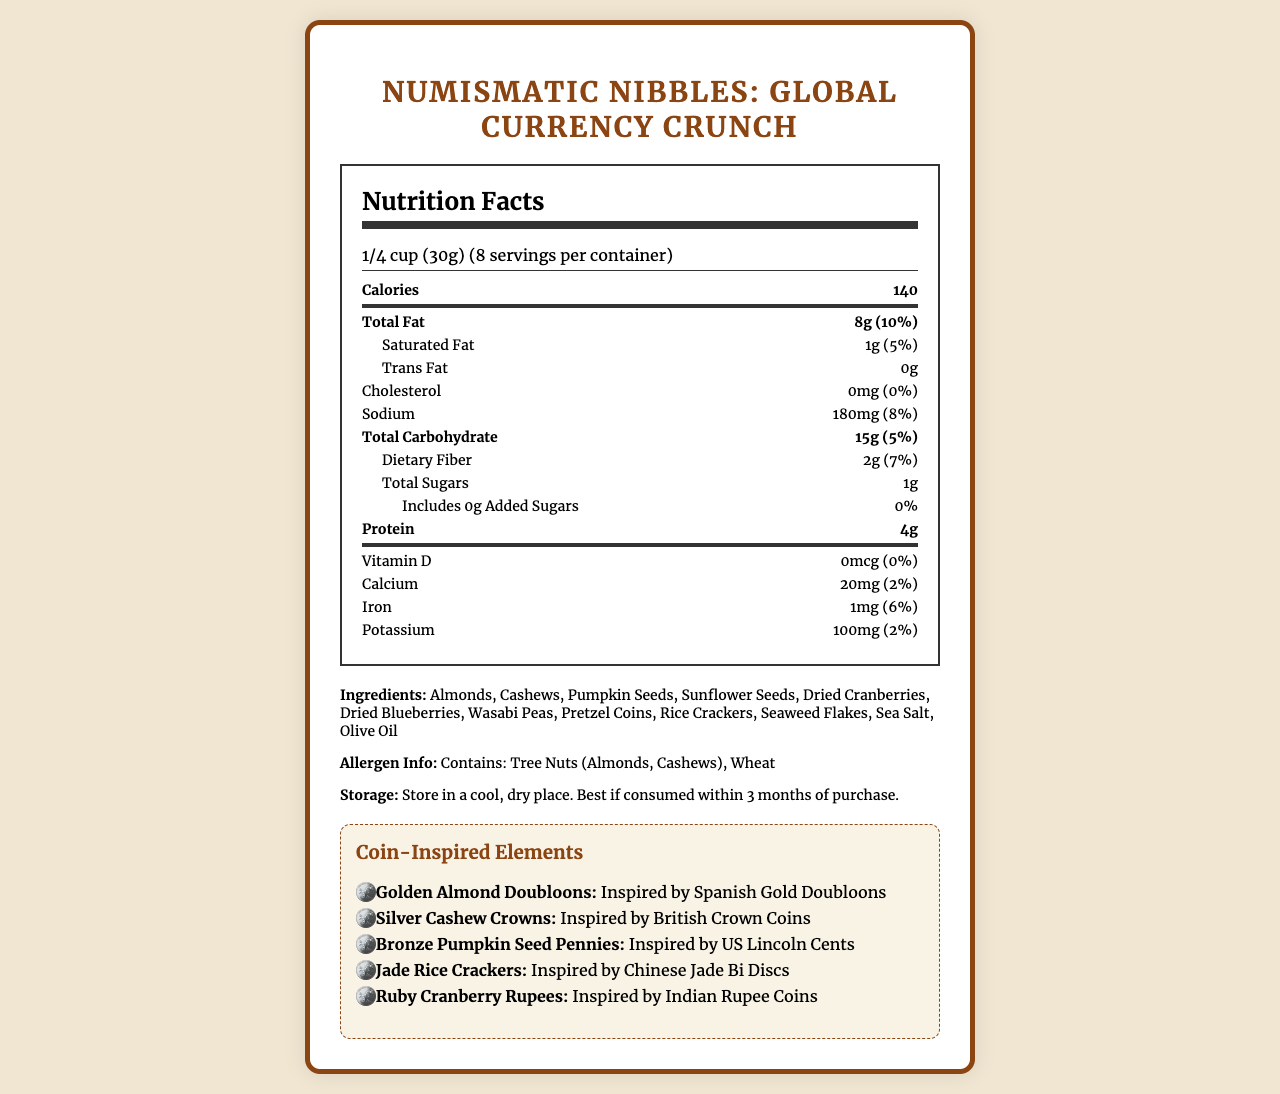what is the serving size? The serving size is listed as "1/4 cup (30g)" in the nutritional facts label.
Answer: 1/4 cup (30g) how many calories per serving? The nutritional facts label indicates that there are 140 calories per serving.
Answer: 140 what ingredients are used in Numismatic Nibbles? The ingredients list includes: Almonds, Cashews, Pumpkin Seeds, Sunflower Seeds, Dried Cranberries, Dried Blueberries, Wasabi Peas, Pretzel Coins, Rice Crackers, Seaweed Flakes, Sea Salt, Olive Oil.
Answer: Almonds, Cashews, Pumpkin Seeds, Sunflower Seeds, Dried Cranberries, Dried Blueberries, Wasabi Peas, Pretzel Coins, Rice Crackers, Seaweed Flakes, Sea Salt, Olive Oil what is the daily value percentage of total fat? The nutritional facts label shows that the daily value percentage of total fat is 10%.
Answer: 10% how much protein does each serving contain? Each serving contains 4g of protein as indicated in the nutritional facts section.
Answer: 4g how many servings are in one container? A. 5 B. 6 C. 8 The document states there are 8 servings per container.
Answer: C which of the following coin-inspired elements are in the snack mix? I. Golden Almond Doubloons II. Silver Cashew Crowns III. Chocolate Coins IV. Ruby Cranberry Rupees The coin-inspired elements listed are Golden Almond Doubloons, Silver Cashew Crowns, and Ruby Cranberry Rupees. Chocolate Coins are not mentioned.
Answer: I, II, IV does the product contain any cholesterol? According to the document, the product contains 0mg of cholesterol which means it has no cholesterol.
Answer: No is this product gluten-free? The allergen info indicates the presence of wheat, which means it is not gluten-free.
Answer: No describe the main idea of this document. The main idea is to present the nutritional details, ingredient list, allergen information, and unique coin-inspired concept of the "Numismatic Nibbles: Global Currency Crunch" snack mix. It highlights the product’s appeal to coin collectors and food lovers, and also stresses the responsible sourcing of ingredients and packaging sustainability.
Answer: The document provides nutritional facts, ingredient information, and allergen info for the gourmet snack mix product "Numismatic Nibbles: Global Currency Crunch." It also describes how the snack mix is designed to resemble various international coins and provides details about the coin-inspired elements. The product is positioned as a unique treat for coin collectors and food enthusiasts. what is the amount of dietary fiber per serving? The document states that there are 2g of dietary fiber per serving.
Answer: 2g which vitamin is included in the product? Vitamin D is present in 0mcg, meaning there are no added vitamins.
Answer: None where should this product be stored? The storage instructions recommend storing the product in a cool, dry place.
Answer: In a cool, dry place how many added sugars are in each serving? The nutritional facts indicate that there are 0g of added sugars per serving.
Answer: 0g does the snack mix source its ingredients responsibly? The document mentions that the ingredients are sourced from responsible farmers and producers worldwide, and the packaging is recyclable.
Answer: Yes is the snack mix specifically designed for shoppers who prefer online purchasing? The product description suggests that the snack mix appeals to people who enjoy the flavors of different cultures without the need for online shopping.
Answer: No what country inspired the Jade Rice Crackers? The Jade Rice Crackers are inspired by Chinese Jade Bi Discs as indicated in the coin-inspired elements section.
Answer: China what is the sodium content per serving? The nutritional facts list 180mg of sodium per serving.
Answer: 180mg does the product contain peanuts? The document states the product is made in a facility that processes peanuts, but it doesn't specify if peanuts are in the product itself.
Answer: Cannot be determined what coin inspired the Golden Almond Doubloons? The Golden Almond Doubloons are inspired by Spanish Gold Doubloons as described in the coin-inspired elements section.
Answer: Spanish Gold Doubloons 